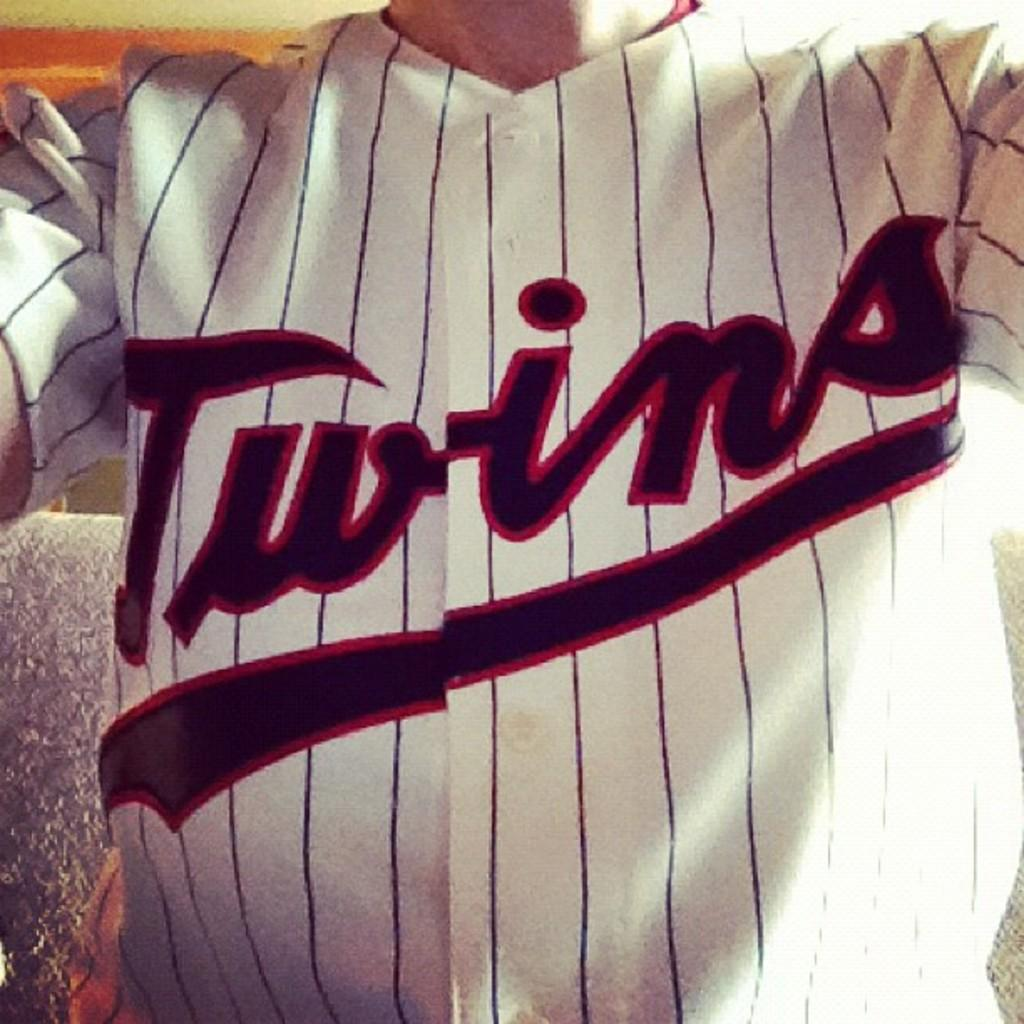<image>
Describe the image concisely. a jersey that has the name Twins on it 